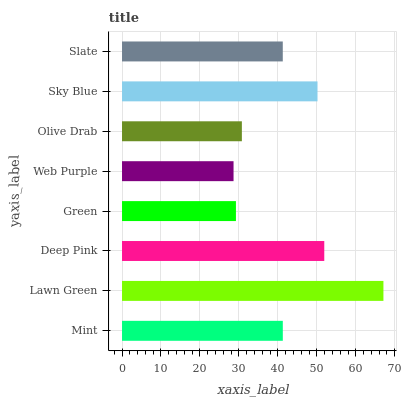Is Web Purple the minimum?
Answer yes or no. Yes. Is Lawn Green the maximum?
Answer yes or no. Yes. Is Deep Pink the minimum?
Answer yes or no. No. Is Deep Pink the maximum?
Answer yes or no. No. Is Lawn Green greater than Deep Pink?
Answer yes or no. Yes. Is Deep Pink less than Lawn Green?
Answer yes or no. Yes. Is Deep Pink greater than Lawn Green?
Answer yes or no. No. Is Lawn Green less than Deep Pink?
Answer yes or no. No. Is Mint the high median?
Answer yes or no. Yes. Is Slate the low median?
Answer yes or no. Yes. Is Sky Blue the high median?
Answer yes or no. No. Is Web Purple the low median?
Answer yes or no. No. 